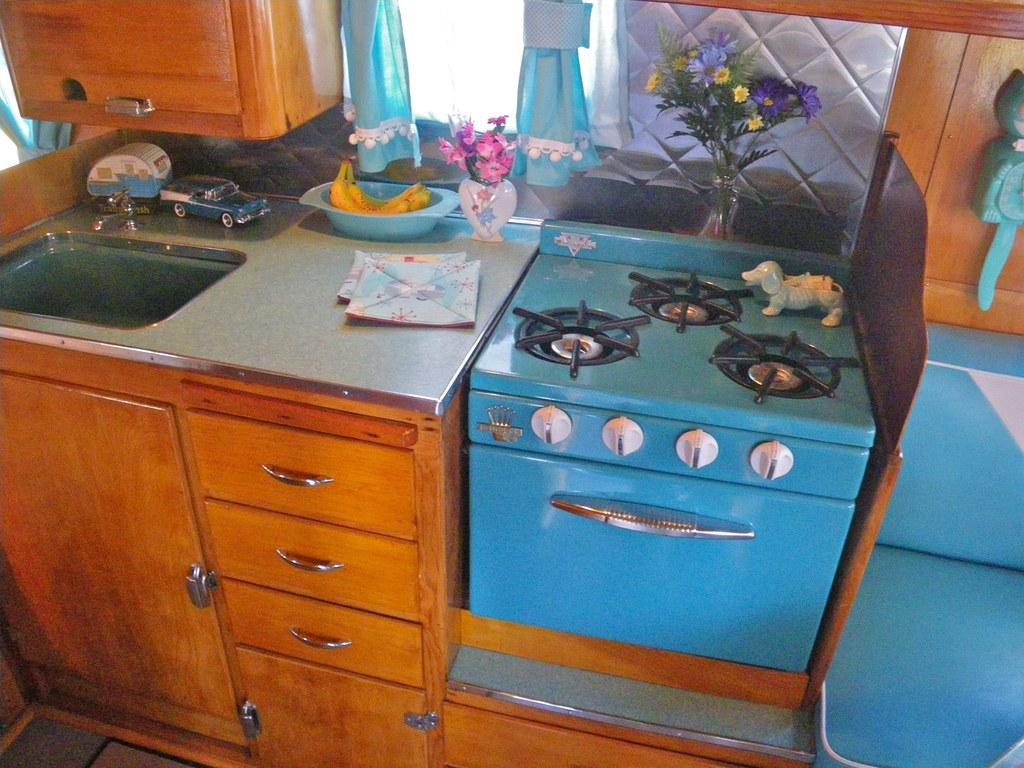Can you describe this image briefly? In this image there are cupboards, sink, tap, toys, bananas, flowers, vases, curtains, stove and objects.   